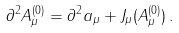<formula> <loc_0><loc_0><loc_500><loc_500>\partial ^ { 2 } A _ { \mu } ^ { ( 0 ) } = \partial ^ { 2 } a _ { \mu } + J _ { \mu } ( A _ { \mu } ^ { ( 0 ) } ) \, .</formula> 